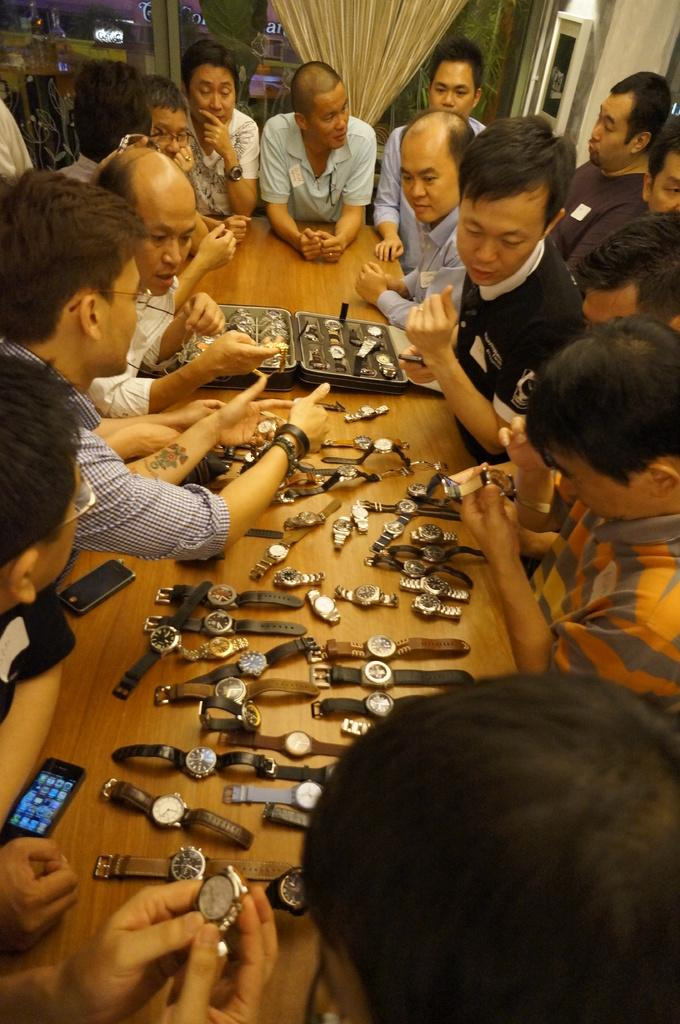What is happening around the table in the image? There are persons around the table in the image. What items can be seen on the table? There are watches, a box, and mobiles on the table. What can be seen in the background of the image? There is a curtain, a frame, and a glass in the background. What type of toys can be seen in the image? There are no toys present in the image. What is the attraction that draws people to the table in the image? There is no attraction mentioned in the image; the persons are simply around the table. 